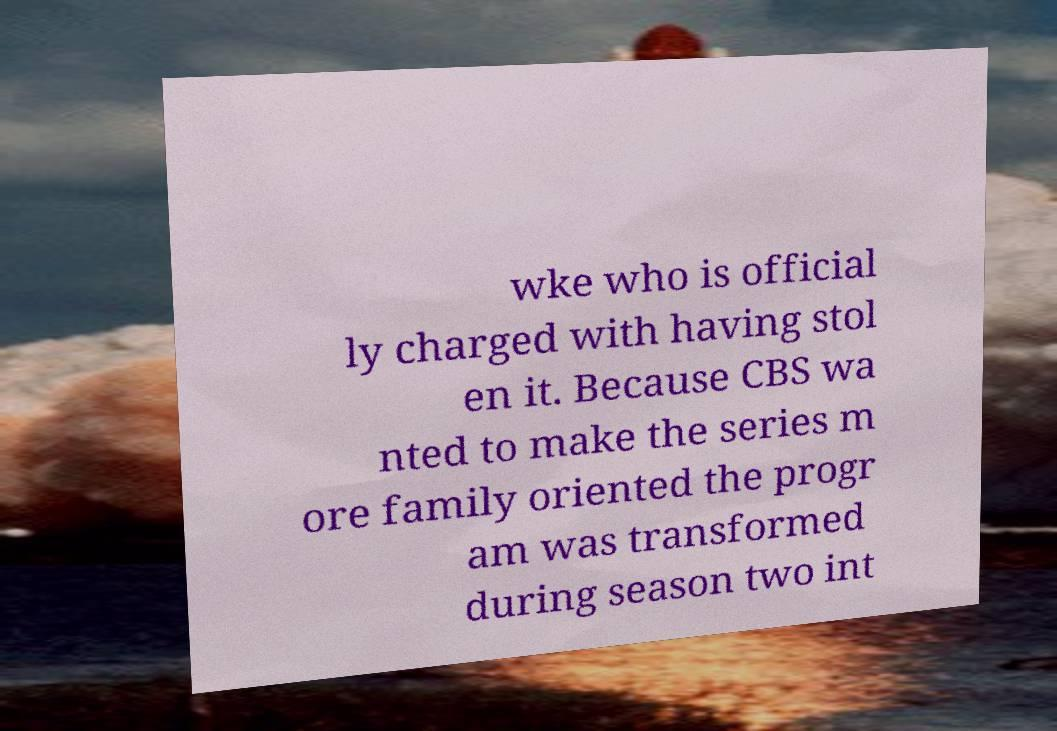Could you assist in decoding the text presented in this image and type it out clearly? wke who is official ly charged with having stol en it. Because CBS wa nted to make the series m ore family oriented the progr am was transformed during season two int 